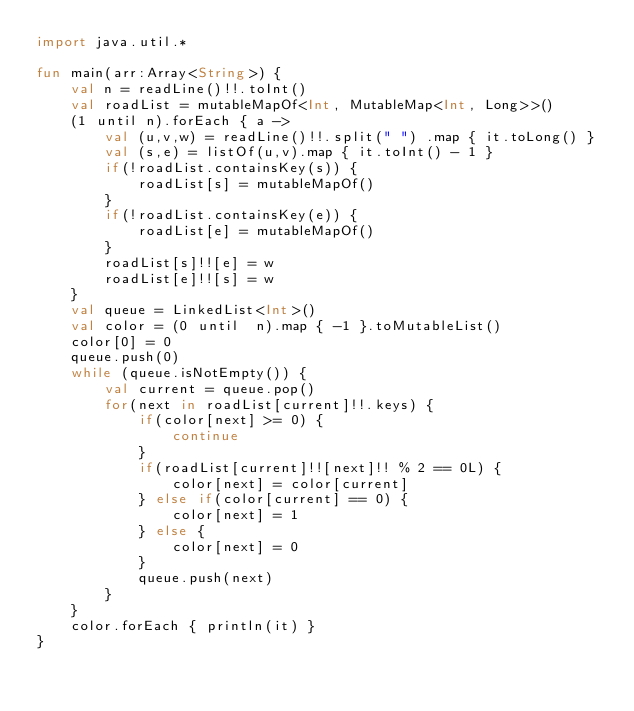Convert code to text. <code><loc_0><loc_0><loc_500><loc_500><_Kotlin_>import java.util.*

fun main(arr:Array<String>) {
    val n = readLine()!!.toInt()
    val roadList = mutableMapOf<Int, MutableMap<Int, Long>>()
    (1 until n).forEach { a ->
        val (u,v,w) = readLine()!!.split(" ") .map { it.toLong() }
        val (s,e) = listOf(u,v).map { it.toInt() - 1 }
        if(!roadList.containsKey(s)) {
            roadList[s] = mutableMapOf()
        }
        if(!roadList.containsKey(e)) {
            roadList[e] = mutableMapOf()
        }
        roadList[s]!![e] = w
        roadList[e]!![s] = w
    }
    val queue = LinkedList<Int>()
    val color = (0 until  n).map { -1 }.toMutableList()
    color[0] = 0
    queue.push(0)
    while (queue.isNotEmpty()) {
        val current = queue.pop()
        for(next in roadList[current]!!.keys) {
            if(color[next] >= 0) {
                continue
            }
            if(roadList[current]!![next]!! % 2 == 0L) {
                color[next] = color[current]
            } else if(color[current] == 0) {
                color[next] = 1
            } else {
                color[next] = 0
            }
            queue.push(next)
        }
    }
    color.forEach { println(it) }
}
</code> 